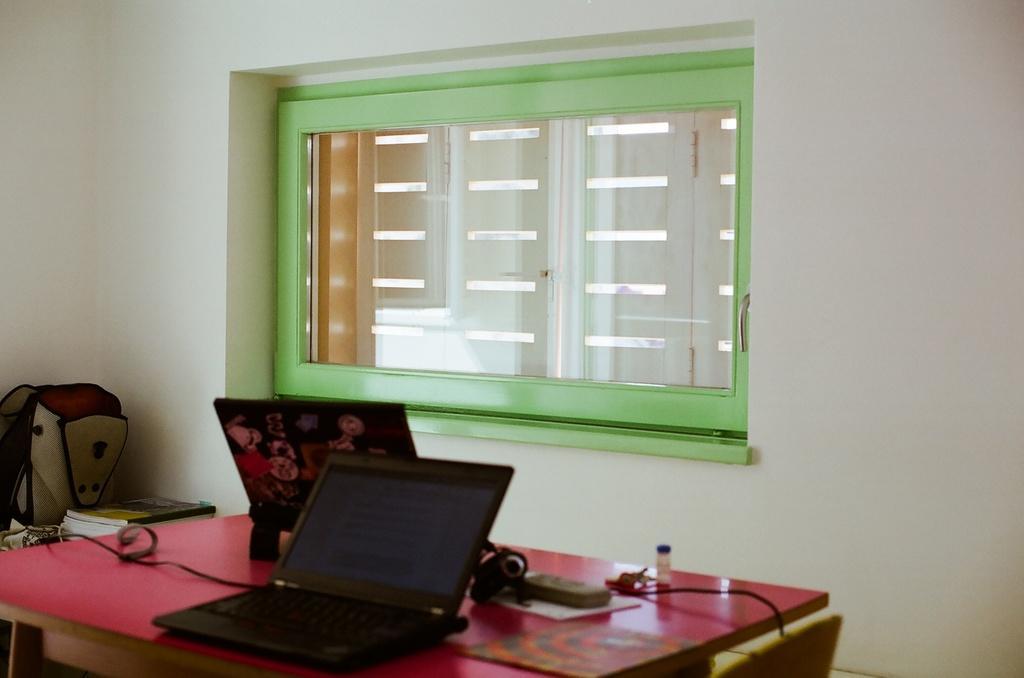In one or two sentences, can you explain what this image depicts? This is the picture taken in a room, this is a table on the table there are laptops, camera and some items. To the left side of the table there are books and a bag. Behind the table there are glass window and a wall. 